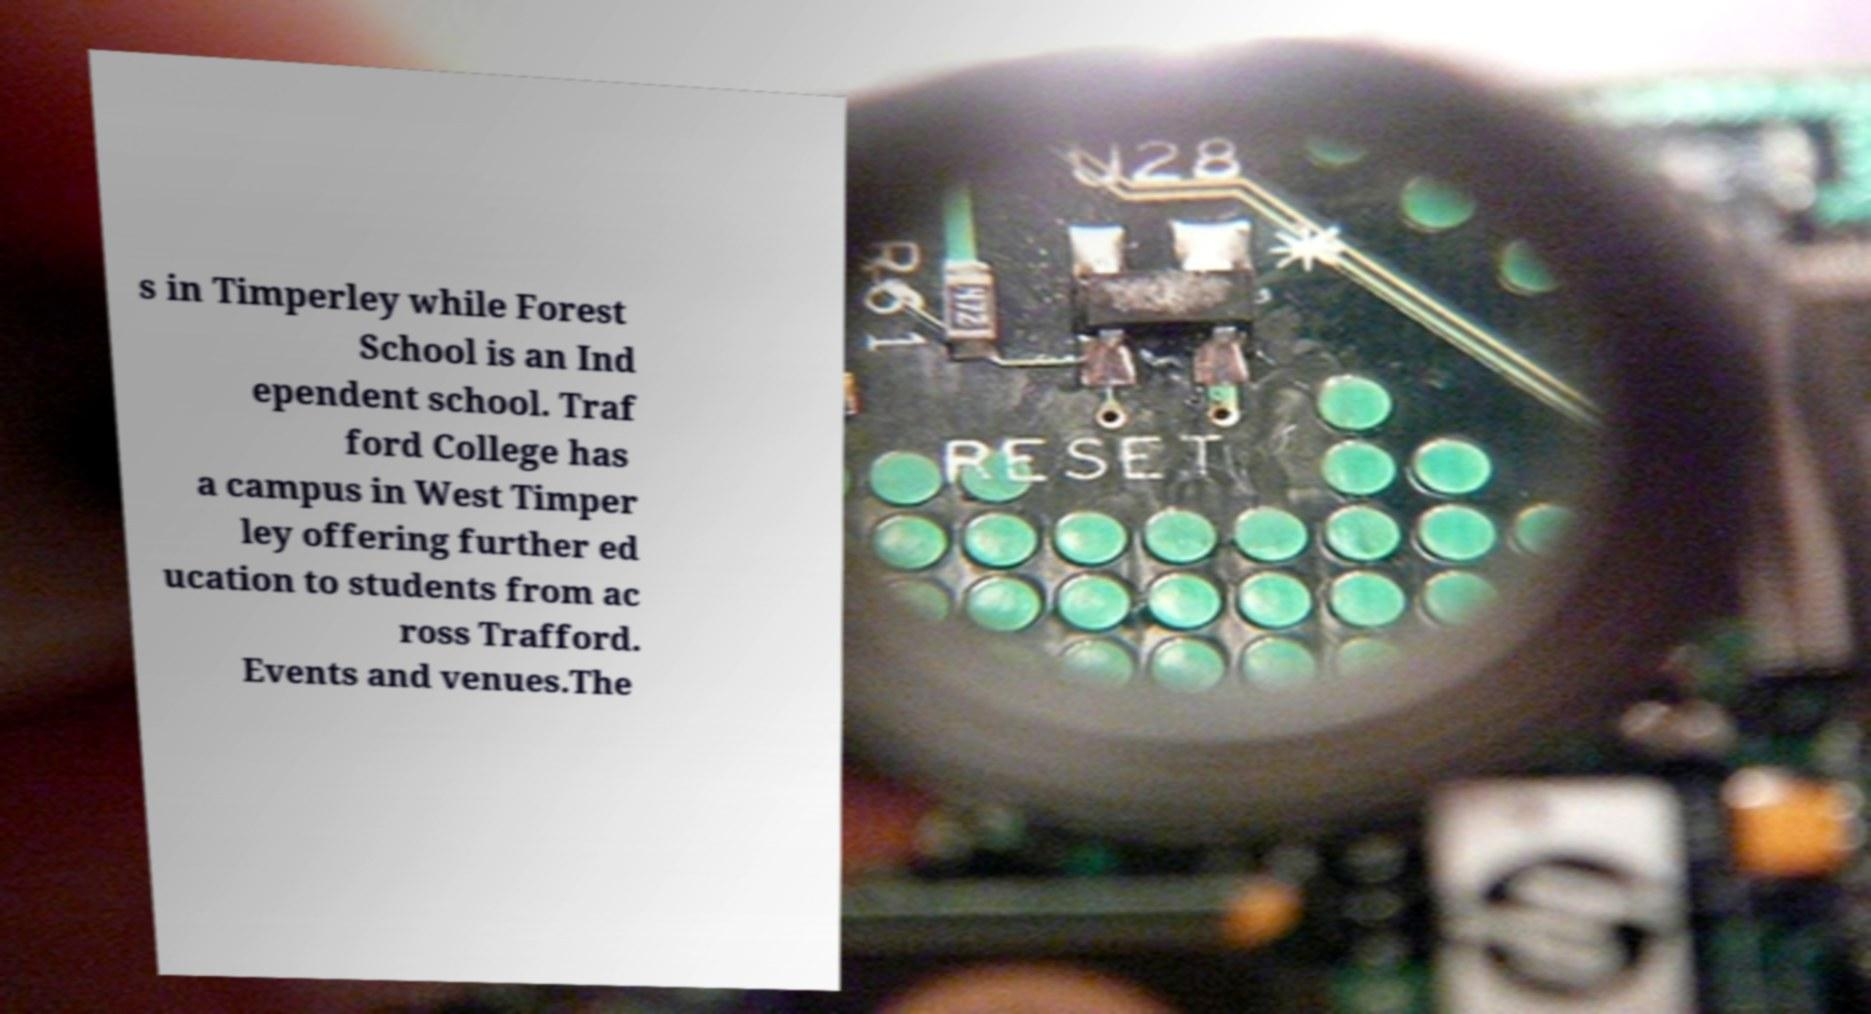What messages or text are displayed in this image? I need them in a readable, typed format. s in Timperley while Forest School is an Ind ependent school. Traf ford College has a campus in West Timper ley offering further ed ucation to students from ac ross Trafford. Events and venues.The 